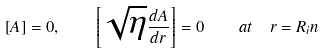Convert formula to latex. <formula><loc_0><loc_0><loc_500><loc_500>\left [ A \right ] = 0 , \quad \left [ \sqrt { \eta } \frac { d A } { d r } \right ] = 0 \quad a t \ \ r = R _ { i } n</formula> 